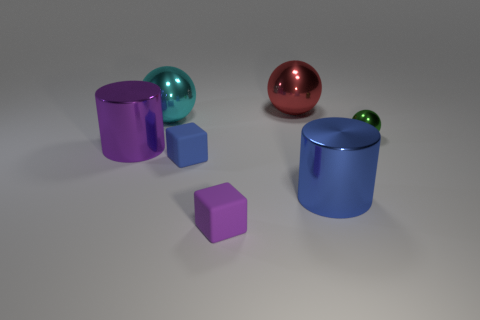Add 2 cyan balls. How many objects exist? 9 Subtract all blocks. How many objects are left? 5 Subtract 1 green balls. How many objects are left? 6 Subtract all red metal spheres. Subtract all big cyan spheres. How many objects are left? 5 Add 4 blue matte objects. How many blue matte objects are left? 5 Add 6 metallic cylinders. How many metallic cylinders exist? 8 